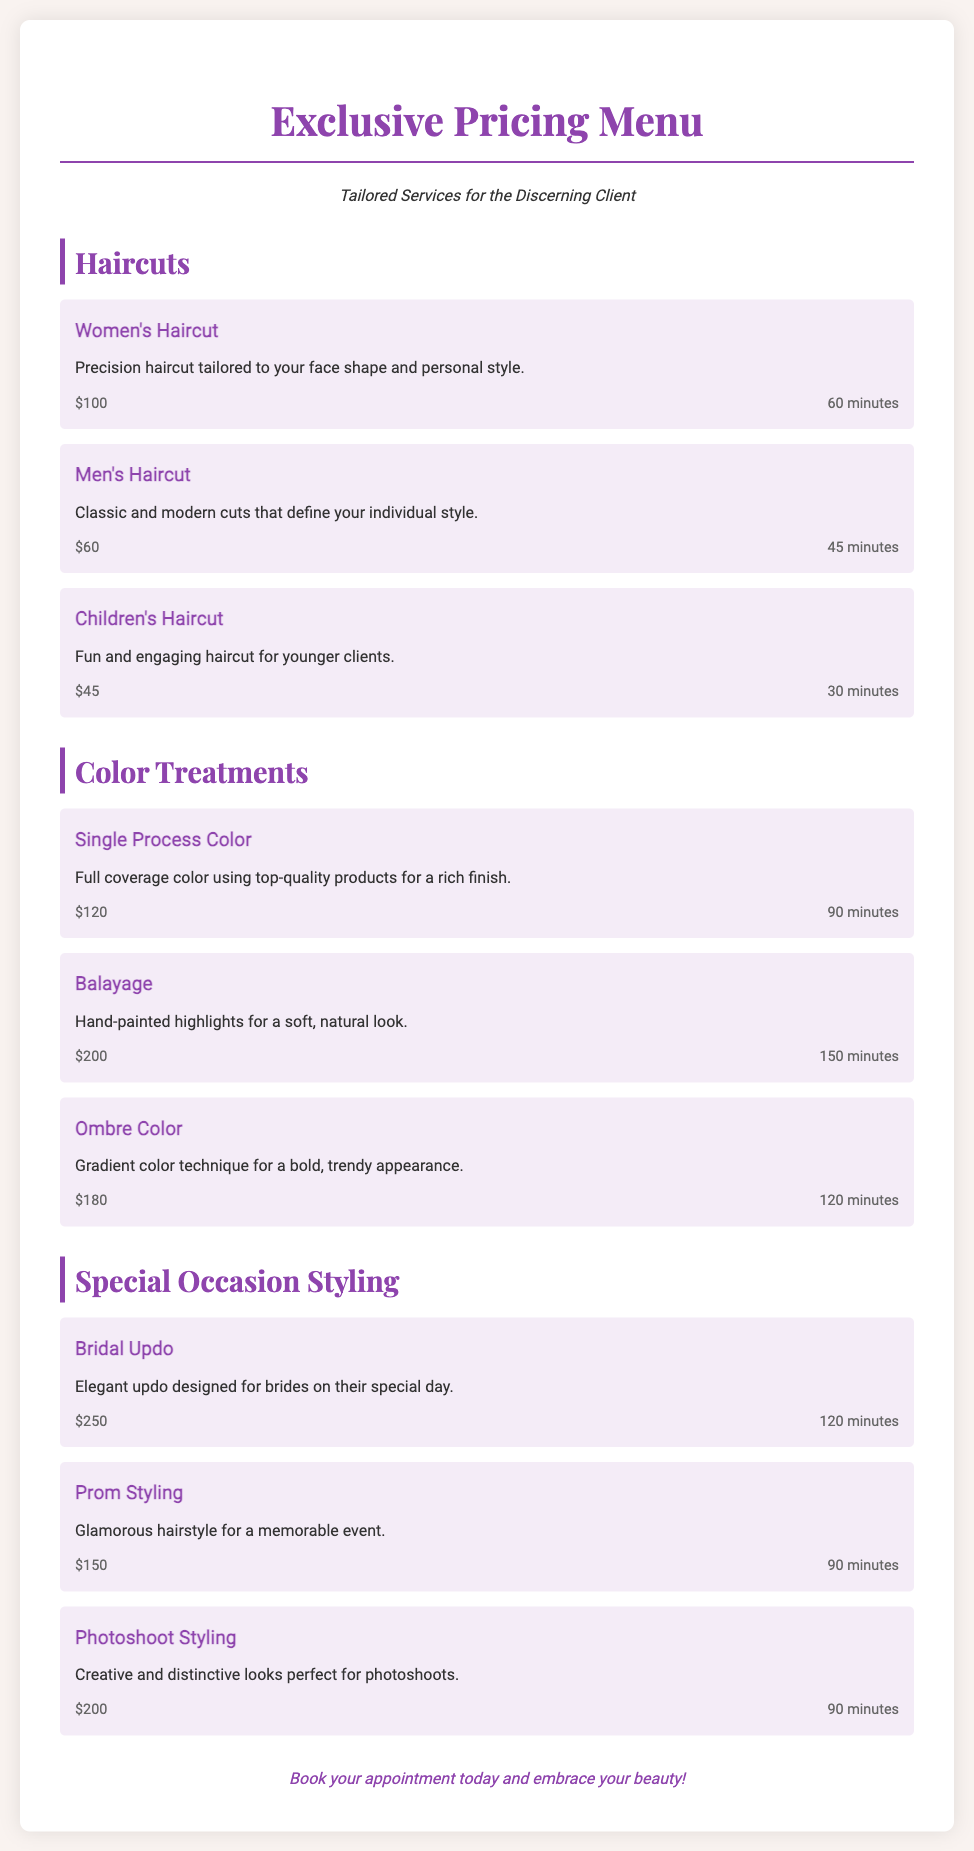What is the price of a Women's Haircut? The price for a Women's Haircut is listed in the Haircuts section of the document.
Answer: $100 How long does a Balayage treatment take? The duration for a Balayage treatment is included in the Color Treatments section.
Answer: 150 minutes What is the description of the Bridal Updo service? The document provides descriptions for each special occasion styling service, including the Bridal Updo.
Answer: Elegant updo designed for brides on their special day How much is a Children's Haircut? The price for a Children's Haircut can be found in the Haircuts section of the menu.
Answer: $45 Which service costs the most in the Color Treatments section? The Color Treatments section lists services with their prices; the highest priced service indicates the most expensive option.
Answer: Balayage What type of service is a Photoshoot Styling? The menu categorizes services into different types, including Special Occasion Styling, under which Photoshoot Styling falls.
Answer: Special Occasion Styling How many minutes does a Single Process Color take? The time allocated for a Single Process Color is specified in the Color Treatments section.
Answer: 90 minutes What is the price for Prom Styling? The price for Prom Styling is found within the Special Occasion Styling section of the menu.
Answer: $150 What is the service description for Ombre Color? The document includes service descriptions, and the Ombre Color description provides specific details about that service.
Answer: Gradient color technique for a bold, trendy appearance 